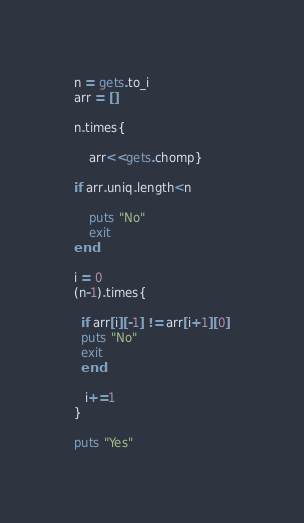Convert code to text. <code><loc_0><loc_0><loc_500><loc_500><_Ruby_>n = gets.to_i
arr = []

n.times{
    
    arr<<gets.chomp}
    
if arr.uniq.length<n
    
    puts "No"
    exit
end

i = 0
(n-1).times{
    
  if arr[i][-1] != arr[i+1][0]
  puts "No"
  exit
  end
    
   i+=1 
}

puts "Yes"

</code> 